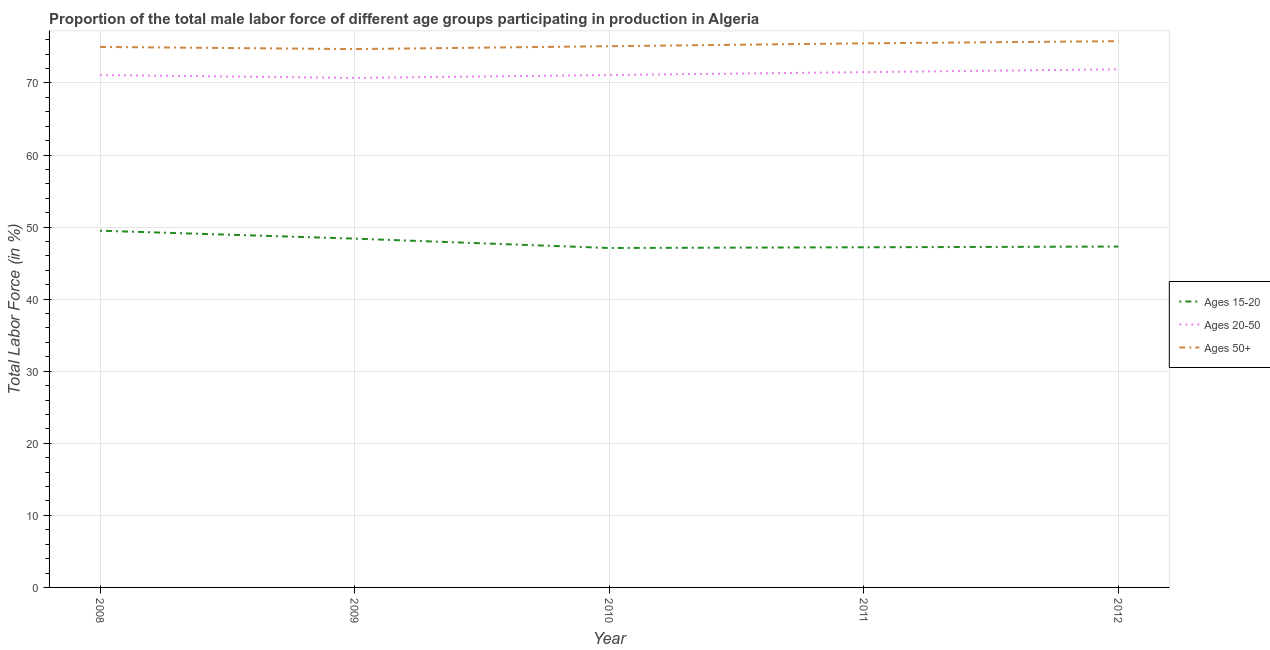How many different coloured lines are there?
Provide a succinct answer. 3. Does the line corresponding to percentage of male labor force above age 50 intersect with the line corresponding to percentage of male labor force within the age group 20-50?
Ensure brevity in your answer.  No. Is the number of lines equal to the number of legend labels?
Ensure brevity in your answer.  Yes. What is the percentage of male labor force above age 50 in 2009?
Your response must be concise. 74.7. Across all years, what is the maximum percentage of male labor force within the age group 20-50?
Keep it short and to the point. 71.9. Across all years, what is the minimum percentage of male labor force within the age group 20-50?
Provide a succinct answer. 70.7. In which year was the percentage of male labor force within the age group 15-20 maximum?
Give a very brief answer. 2008. In which year was the percentage of male labor force within the age group 15-20 minimum?
Your answer should be very brief. 2010. What is the total percentage of male labor force within the age group 15-20 in the graph?
Make the answer very short. 239.5. What is the difference between the percentage of male labor force within the age group 20-50 in 2008 and that in 2012?
Make the answer very short. -0.8. What is the difference between the percentage of male labor force within the age group 15-20 in 2011 and the percentage of male labor force within the age group 20-50 in 2009?
Make the answer very short. -23.5. What is the average percentage of male labor force within the age group 15-20 per year?
Provide a succinct answer. 47.9. In the year 2012, what is the difference between the percentage of male labor force above age 50 and percentage of male labor force within the age group 20-50?
Keep it short and to the point. 3.9. What is the ratio of the percentage of male labor force within the age group 20-50 in 2009 to that in 2010?
Make the answer very short. 0.99. Is the percentage of male labor force within the age group 15-20 in 2009 less than that in 2010?
Give a very brief answer. No. Is the difference between the percentage of male labor force within the age group 20-50 in 2008 and 2012 greater than the difference between the percentage of male labor force within the age group 15-20 in 2008 and 2012?
Provide a succinct answer. No. What is the difference between the highest and the second highest percentage of male labor force above age 50?
Your response must be concise. 0.3. What is the difference between the highest and the lowest percentage of male labor force above age 50?
Your answer should be compact. 1.1. Is the sum of the percentage of male labor force within the age group 20-50 in 2008 and 2010 greater than the maximum percentage of male labor force within the age group 15-20 across all years?
Keep it short and to the point. Yes. Is it the case that in every year, the sum of the percentage of male labor force within the age group 15-20 and percentage of male labor force within the age group 20-50 is greater than the percentage of male labor force above age 50?
Keep it short and to the point. Yes. Is the percentage of male labor force within the age group 20-50 strictly less than the percentage of male labor force above age 50 over the years?
Offer a very short reply. Yes. What is the difference between two consecutive major ticks on the Y-axis?
Give a very brief answer. 10. Does the graph contain any zero values?
Make the answer very short. No. Where does the legend appear in the graph?
Offer a very short reply. Center right. How many legend labels are there?
Give a very brief answer. 3. What is the title of the graph?
Provide a succinct answer. Proportion of the total male labor force of different age groups participating in production in Algeria. What is the label or title of the X-axis?
Provide a short and direct response. Year. What is the label or title of the Y-axis?
Provide a short and direct response. Total Labor Force (in %). What is the Total Labor Force (in %) of Ages 15-20 in 2008?
Your answer should be very brief. 49.5. What is the Total Labor Force (in %) in Ages 20-50 in 2008?
Ensure brevity in your answer.  71.1. What is the Total Labor Force (in %) of Ages 50+ in 2008?
Provide a short and direct response. 75. What is the Total Labor Force (in %) of Ages 15-20 in 2009?
Your answer should be very brief. 48.4. What is the Total Labor Force (in %) of Ages 20-50 in 2009?
Provide a succinct answer. 70.7. What is the Total Labor Force (in %) of Ages 50+ in 2009?
Offer a very short reply. 74.7. What is the Total Labor Force (in %) of Ages 15-20 in 2010?
Your answer should be compact. 47.1. What is the Total Labor Force (in %) in Ages 20-50 in 2010?
Your response must be concise. 71.1. What is the Total Labor Force (in %) in Ages 50+ in 2010?
Provide a succinct answer. 75.1. What is the Total Labor Force (in %) of Ages 15-20 in 2011?
Provide a short and direct response. 47.2. What is the Total Labor Force (in %) of Ages 20-50 in 2011?
Keep it short and to the point. 71.5. What is the Total Labor Force (in %) of Ages 50+ in 2011?
Make the answer very short. 75.5. What is the Total Labor Force (in %) in Ages 15-20 in 2012?
Your response must be concise. 47.3. What is the Total Labor Force (in %) in Ages 20-50 in 2012?
Offer a terse response. 71.9. What is the Total Labor Force (in %) of Ages 50+ in 2012?
Offer a terse response. 75.8. Across all years, what is the maximum Total Labor Force (in %) in Ages 15-20?
Provide a short and direct response. 49.5. Across all years, what is the maximum Total Labor Force (in %) in Ages 20-50?
Your response must be concise. 71.9. Across all years, what is the maximum Total Labor Force (in %) in Ages 50+?
Give a very brief answer. 75.8. Across all years, what is the minimum Total Labor Force (in %) in Ages 15-20?
Give a very brief answer. 47.1. Across all years, what is the minimum Total Labor Force (in %) of Ages 20-50?
Provide a succinct answer. 70.7. Across all years, what is the minimum Total Labor Force (in %) of Ages 50+?
Your answer should be very brief. 74.7. What is the total Total Labor Force (in %) in Ages 15-20 in the graph?
Ensure brevity in your answer.  239.5. What is the total Total Labor Force (in %) of Ages 20-50 in the graph?
Keep it short and to the point. 356.3. What is the total Total Labor Force (in %) of Ages 50+ in the graph?
Keep it short and to the point. 376.1. What is the difference between the Total Labor Force (in %) of Ages 20-50 in 2008 and that in 2009?
Provide a succinct answer. 0.4. What is the difference between the Total Labor Force (in %) in Ages 50+ in 2008 and that in 2009?
Your answer should be compact. 0.3. What is the difference between the Total Labor Force (in %) in Ages 15-20 in 2008 and that in 2011?
Provide a short and direct response. 2.3. What is the difference between the Total Labor Force (in %) of Ages 15-20 in 2009 and that in 2010?
Your response must be concise. 1.3. What is the difference between the Total Labor Force (in %) of Ages 20-50 in 2009 and that in 2010?
Ensure brevity in your answer.  -0.4. What is the difference between the Total Labor Force (in %) of Ages 50+ in 2009 and that in 2010?
Make the answer very short. -0.4. What is the difference between the Total Labor Force (in %) of Ages 15-20 in 2009 and that in 2011?
Your response must be concise. 1.2. What is the difference between the Total Labor Force (in %) of Ages 20-50 in 2009 and that in 2012?
Offer a very short reply. -1.2. What is the difference between the Total Labor Force (in %) of Ages 50+ in 2009 and that in 2012?
Your answer should be very brief. -1.1. What is the difference between the Total Labor Force (in %) in Ages 15-20 in 2010 and that in 2011?
Give a very brief answer. -0.1. What is the difference between the Total Labor Force (in %) of Ages 20-50 in 2010 and that in 2011?
Provide a succinct answer. -0.4. What is the difference between the Total Labor Force (in %) of Ages 50+ in 2010 and that in 2011?
Offer a very short reply. -0.4. What is the difference between the Total Labor Force (in %) of Ages 15-20 in 2011 and that in 2012?
Give a very brief answer. -0.1. What is the difference between the Total Labor Force (in %) of Ages 50+ in 2011 and that in 2012?
Offer a very short reply. -0.3. What is the difference between the Total Labor Force (in %) of Ages 15-20 in 2008 and the Total Labor Force (in %) of Ages 20-50 in 2009?
Your answer should be very brief. -21.2. What is the difference between the Total Labor Force (in %) in Ages 15-20 in 2008 and the Total Labor Force (in %) in Ages 50+ in 2009?
Provide a succinct answer. -25.2. What is the difference between the Total Labor Force (in %) of Ages 20-50 in 2008 and the Total Labor Force (in %) of Ages 50+ in 2009?
Offer a very short reply. -3.6. What is the difference between the Total Labor Force (in %) in Ages 15-20 in 2008 and the Total Labor Force (in %) in Ages 20-50 in 2010?
Ensure brevity in your answer.  -21.6. What is the difference between the Total Labor Force (in %) in Ages 15-20 in 2008 and the Total Labor Force (in %) in Ages 50+ in 2010?
Provide a succinct answer. -25.6. What is the difference between the Total Labor Force (in %) in Ages 20-50 in 2008 and the Total Labor Force (in %) in Ages 50+ in 2010?
Your response must be concise. -4. What is the difference between the Total Labor Force (in %) of Ages 15-20 in 2008 and the Total Labor Force (in %) of Ages 20-50 in 2012?
Provide a succinct answer. -22.4. What is the difference between the Total Labor Force (in %) in Ages 15-20 in 2008 and the Total Labor Force (in %) in Ages 50+ in 2012?
Provide a short and direct response. -26.3. What is the difference between the Total Labor Force (in %) of Ages 15-20 in 2009 and the Total Labor Force (in %) of Ages 20-50 in 2010?
Your response must be concise. -22.7. What is the difference between the Total Labor Force (in %) in Ages 15-20 in 2009 and the Total Labor Force (in %) in Ages 50+ in 2010?
Ensure brevity in your answer.  -26.7. What is the difference between the Total Labor Force (in %) in Ages 20-50 in 2009 and the Total Labor Force (in %) in Ages 50+ in 2010?
Your answer should be very brief. -4.4. What is the difference between the Total Labor Force (in %) in Ages 15-20 in 2009 and the Total Labor Force (in %) in Ages 20-50 in 2011?
Your response must be concise. -23.1. What is the difference between the Total Labor Force (in %) of Ages 15-20 in 2009 and the Total Labor Force (in %) of Ages 50+ in 2011?
Your response must be concise. -27.1. What is the difference between the Total Labor Force (in %) of Ages 20-50 in 2009 and the Total Labor Force (in %) of Ages 50+ in 2011?
Provide a succinct answer. -4.8. What is the difference between the Total Labor Force (in %) of Ages 15-20 in 2009 and the Total Labor Force (in %) of Ages 20-50 in 2012?
Give a very brief answer. -23.5. What is the difference between the Total Labor Force (in %) in Ages 15-20 in 2009 and the Total Labor Force (in %) in Ages 50+ in 2012?
Give a very brief answer. -27.4. What is the difference between the Total Labor Force (in %) in Ages 20-50 in 2009 and the Total Labor Force (in %) in Ages 50+ in 2012?
Keep it short and to the point. -5.1. What is the difference between the Total Labor Force (in %) in Ages 15-20 in 2010 and the Total Labor Force (in %) in Ages 20-50 in 2011?
Your answer should be compact. -24.4. What is the difference between the Total Labor Force (in %) in Ages 15-20 in 2010 and the Total Labor Force (in %) in Ages 50+ in 2011?
Keep it short and to the point. -28.4. What is the difference between the Total Labor Force (in %) in Ages 15-20 in 2010 and the Total Labor Force (in %) in Ages 20-50 in 2012?
Make the answer very short. -24.8. What is the difference between the Total Labor Force (in %) of Ages 15-20 in 2010 and the Total Labor Force (in %) of Ages 50+ in 2012?
Your response must be concise. -28.7. What is the difference between the Total Labor Force (in %) of Ages 20-50 in 2010 and the Total Labor Force (in %) of Ages 50+ in 2012?
Your answer should be compact. -4.7. What is the difference between the Total Labor Force (in %) of Ages 15-20 in 2011 and the Total Labor Force (in %) of Ages 20-50 in 2012?
Your answer should be very brief. -24.7. What is the difference between the Total Labor Force (in %) in Ages 15-20 in 2011 and the Total Labor Force (in %) in Ages 50+ in 2012?
Provide a short and direct response. -28.6. What is the difference between the Total Labor Force (in %) of Ages 20-50 in 2011 and the Total Labor Force (in %) of Ages 50+ in 2012?
Provide a short and direct response. -4.3. What is the average Total Labor Force (in %) of Ages 15-20 per year?
Your answer should be compact. 47.9. What is the average Total Labor Force (in %) of Ages 20-50 per year?
Provide a short and direct response. 71.26. What is the average Total Labor Force (in %) of Ages 50+ per year?
Keep it short and to the point. 75.22. In the year 2008, what is the difference between the Total Labor Force (in %) of Ages 15-20 and Total Labor Force (in %) of Ages 20-50?
Offer a very short reply. -21.6. In the year 2008, what is the difference between the Total Labor Force (in %) in Ages 15-20 and Total Labor Force (in %) in Ages 50+?
Your response must be concise. -25.5. In the year 2008, what is the difference between the Total Labor Force (in %) in Ages 20-50 and Total Labor Force (in %) in Ages 50+?
Offer a terse response. -3.9. In the year 2009, what is the difference between the Total Labor Force (in %) in Ages 15-20 and Total Labor Force (in %) in Ages 20-50?
Keep it short and to the point. -22.3. In the year 2009, what is the difference between the Total Labor Force (in %) of Ages 15-20 and Total Labor Force (in %) of Ages 50+?
Offer a terse response. -26.3. In the year 2009, what is the difference between the Total Labor Force (in %) of Ages 20-50 and Total Labor Force (in %) of Ages 50+?
Keep it short and to the point. -4. In the year 2010, what is the difference between the Total Labor Force (in %) in Ages 15-20 and Total Labor Force (in %) in Ages 20-50?
Make the answer very short. -24. In the year 2010, what is the difference between the Total Labor Force (in %) of Ages 15-20 and Total Labor Force (in %) of Ages 50+?
Your answer should be very brief. -28. In the year 2011, what is the difference between the Total Labor Force (in %) of Ages 15-20 and Total Labor Force (in %) of Ages 20-50?
Provide a succinct answer. -24.3. In the year 2011, what is the difference between the Total Labor Force (in %) of Ages 15-20 and Total Labor Force (in %) of Ages 50+?
Keep it short and to the point. -28.3. In the year 2011, what is the difference between the Total Labor Force (in %) in Ages 20-50 and Total Labor Force (in %) in Ages 50+?
Offer a terse response. -4. In the year 2012, what is the difference between the Total Labor Force (in %) in Ages 15-20 and Total Labor Force (in %) in Ages 20-50?
Provide a short and direct response. -24.6. In the year 2012, what is the difference between the Total Labor Force (in %) of Ages 15-20 and Total Labor Force (in %) of Ages 50+?
Give a very brief answer. -28.5. What is the ratio of the Total Labor Force (in %) of Ages 15-20 in 2008 to that in 2009?
Provide a succinct answer. 1.02. What is the ratio of the Total Labor Force (in %) of Ages 20-50 in 2008 to that in 2009?
Your answer should be very brief. 1.01. What is the ratio of the Total Labor Force (in %) in Ages 50+ in 2008 to that in 2009?
Give a very brief answer. 1. What is the ratio of the Total Labor Force (in %) of Ages 15-20 in 2008 to that in 2010?
Provide a succinct answer. 1.05. What is the ratio of the Total Labor Force (in %) in Ages 15-20 in 2008 to that in 2011?
Your response must be concise. 1.05. What is the ratio of the Total Labor Force (in %) in Ages 20-50 in 2008 to that in 2011?
Give a very brief answer. 0.99. What is the ratio of the Total Labor Force (in %) in Ages 15-20 in 2008 to that in 2012?
Offer a terse response. 1.05. What is the ratio of the Total Labor Force (in %) of Ages 20-50 in 2008 to that in 2012?
Your answer should be compact. 0.99. What is the ratio of the Total Labor Force (in %) in Ages 50+ in 2008 to that in 2012?
Your answer should be compact. 0.99. What is the ratio of the Total Labor Force (in %) of Ages 15-20 in 2009 to that in 2010?
Provide a succinct answer. 1.03. What is the ratio of the Total Labor Force (in %) in Ages 15-20 in 2009 to that in 2011?
Give a very brief answer. 1.03. What is the ratio of the Total Labor Force (in %) of Ages 15-20 in 2009 to that in 2012?
Give a very brief answer. 1.02. What is the ratio of the Total Labor Force (in %) of Ages 20-50 in 2009 to that in 2012?
Offer a very short reply. 0.98. What is the ratio of the Total Labor Force (in %) in Ages 50+ in 2009 to that in 2012?
Make the answer very short. 0.99. What is the ratio of the Total Labor Force (in %) of Ages 15-20 in 2010 to that in 2011?
Your answer should be very brief. 1. What is the ratio of the Total Labor Force (in %) of Ages 20-50 in 2010 to that in 2011?
Your answer should be very brief. 0.99. What is the ratio of the Total Labor Force (in %) in Ages 15-20 in 2010 to that in 2012?
Offer a terse response. 1. What is the ratio of the Total Labor Force (in %) of Ages 20-50 in 2010 to that in 2012?
Keep it short and to the point. 0.99. What is the ratio of the Total Labor Force (in %) in Ages 20-50 in 2011 to that in 2012?
Keep it short and to the point. 0.99. What is the ratio of the Total Labor Force (in %) of Ages 50+ in 2011 to that in 2012?
Offer a very short reply. 1. What is the difference between the highest and the second highest Total Labor Force (in %) in Ages 15-20?
Your answer should be very brief. 1.1. What is the difference between the highest and the second highest Total Labor Force (in %) in Ages 50+?
Offer a very short reply. 0.3. What is the difference between the highest and the lowest Total Labor Force (in %) of Ages 50+?
Your answer should be compact. 1.1. 